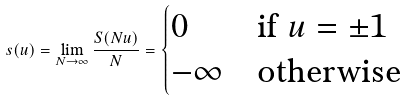<formula> <loc_0><loc_0><loc_500><loc_500>s ( u ) = \lim _ { N \rightarrow \infty } \frac { S ( N u ) } { N } = \begin{cases} 0 & \text {if $u=\pm 1$} \\ - \infty & \text {otherwise} \end{cases}</formula> 